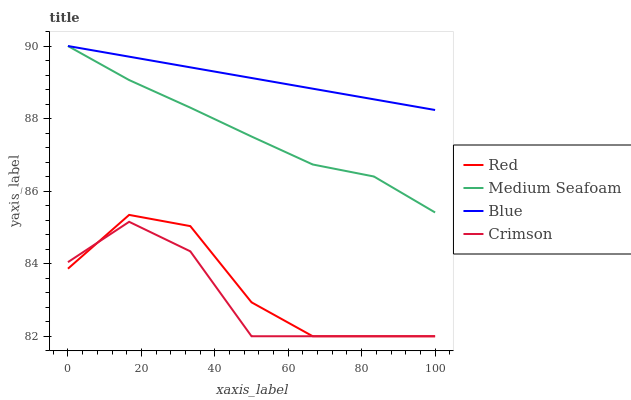Does Medium Seafoam have the minimum area under the curve?
Answer yes or no. No. Does Medium Seafoam have the maximum area under the curve?
Answer yes or no. No. Is Medium Seafoam the smoothest?
Answer yes or no. No. Is Medium Seafoam the roughest?
Answer yes or no. No. Does Medium Seafoam have the lowest value?
Answer yes or no. No. Does Crimson have the highest value?
Answer yes or no. No. Is Crimson less than Blue?
Answer yes or no. Yes. Is Blue greater than Crimson?
Answer yes or no. Yes. Does Crimson intersect Blue?
Answer yes or no. No. 